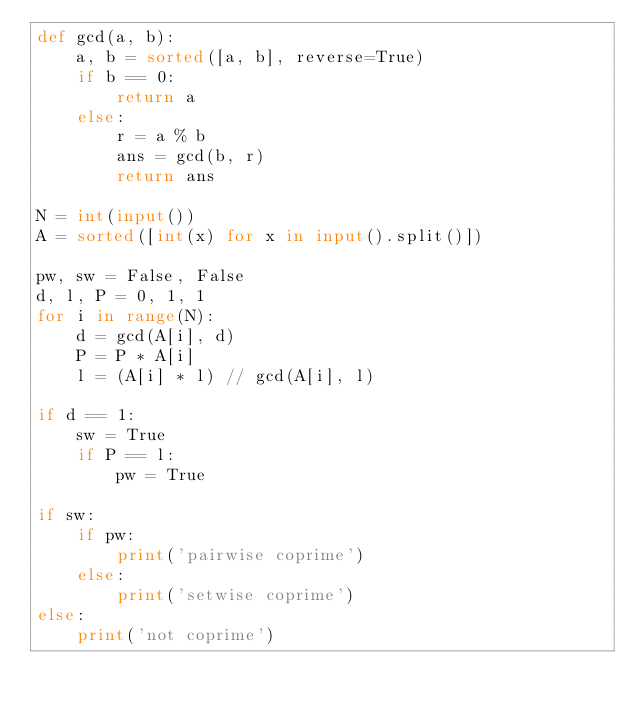Convert code to text. <code><loc_0><loc_0><loc_500><loc_500><_Python_>def gcd(a, b):
    a, b = sorted([a, b], reverse=True)
    if b == 0:
        return a
    else:
        r = a % b
        ans = gcd(b, r)
        return ans

N = int(input())
A = sorted([int(x) for x in input().split()])

pw, sw = False, False
d, l, P = 0, 1, 1
for i in range(N):
    d = gcd(A[i], d)
    P = P * A[i]
    l = (A[i] * l) // gcd(A[i], l)

if d == 1:
    sw = True
    if P == l:
        pw = True

if sw:
    if pw:
        print('pairwise coprime')
    else:
        print('setwise coprime')
else:
    print('not coprime')</code> 